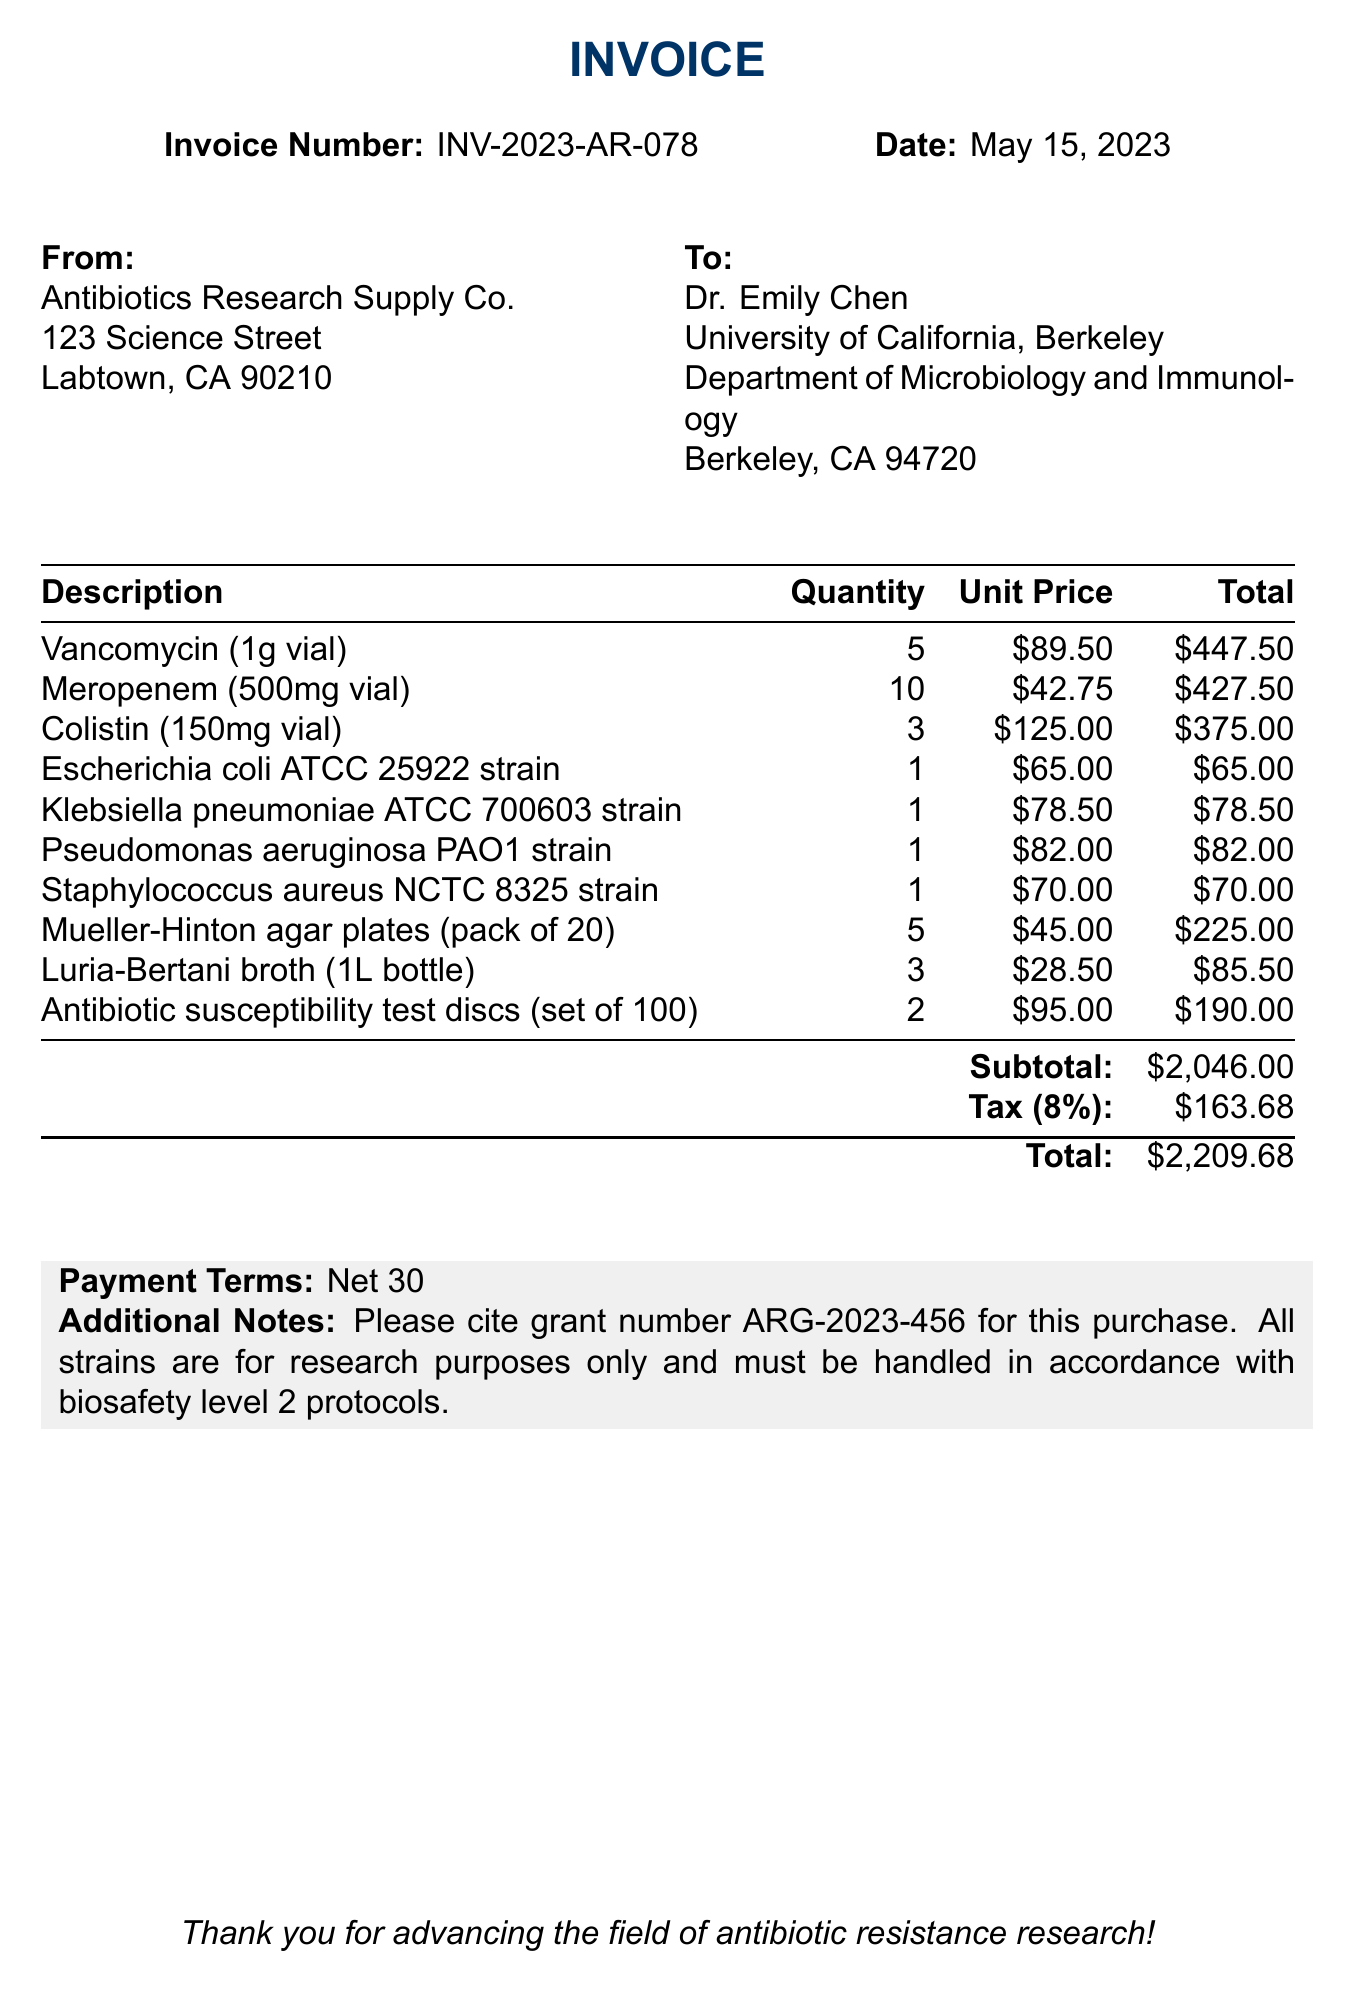What is the invoice number? The invoice number is a unique identifier for this document, mentioned in the header section.
Answer: INV-2023-AR-078 Who is the researcher? The researcher is the individual associated with the invoice, listed in the recipient section.
Answer: Dr. Emily Chen How many vials of Colistin were ordered? The quantity of Colistin vials is given in the itemized section of the invoice.
Answer: 3 What is the total amount including tax? The total amount is calculated as the sum of the subtotal and tax, presented at the bottom of the invoice.
Answer: $2209.68 What is the subtotal before tax? The subtotal is the total of all items before tax is applied, shown in the itemized section.
Answer: $2046.00 What is the tax rate applied to the purchase? The tax rate is specified in the document and is a percentage of the subtotal.
Answer: 8% How many strains of bacteria were ordered? The total number of bacterial strains can be calculated by counting the strains listed in the itemized section.
Answer: 4 What is the payment term specified? The payment term indicates the duration after which the payment is due. This is mentioned near the end of the document.
Answer: Net 30 What additional note is provided regarding the purchase? The additional notes provide important context for handling the strains, found in the footer of the invoice.
Answer: Please cite grant number ARG-2023-456 for this purchase 